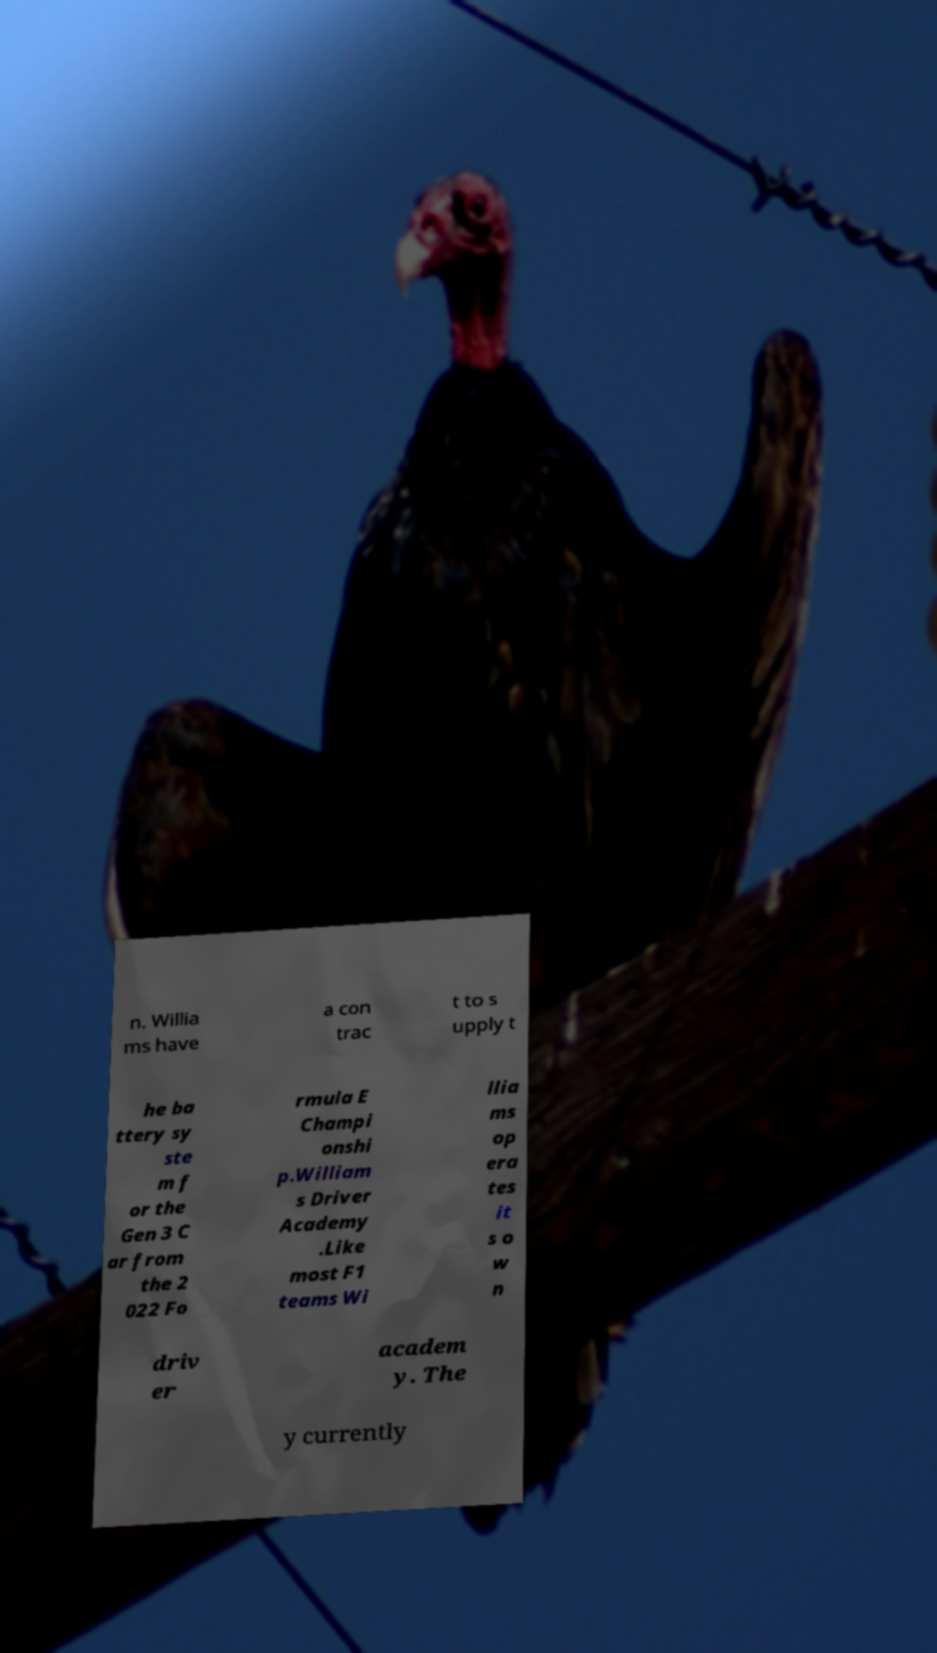There's text embedded in this image that I need extracted. Can you transcribe it verbatim? n. Willia ms have a con trac t to s upply t he ba ttery sy ste m f or the Gen 3 C ar from the 2 022 Fo rmula E Champi onshi p.William s Driver Academy .Like most F1 teams Wi llia ms op era tes it s o w n driv er academ y. The y currently 